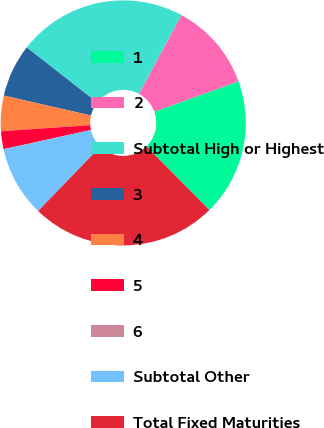<chart> <loc_0><loc_0><loc_500><loc_500><pie_chart><fcel>1<fcel>2<fcel>Subtotal High or Highest<fcel>3<fcel>4<fcel>5<fcel>6<fcel>Subtotal Other<fcel>Total Fixed Maturities<nl><fcel>18.11%<fcel>11.63%<fcel>22.31%<fcel>6.99%<fcel>4.67%<fcel>2.35%<fcel>0.03%<fcel>9.31%<fcel>24.63%<nl></chart> 